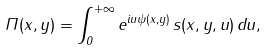<formula> <loc_0><loc_0><loc_500><loc_500>\Pi ( x , y ) = \int _ { 0 } ^ { + \infty } e ^ { i u \psi ( x , y ) } \, s ( x , y , u ) \, d u ,</formula> 